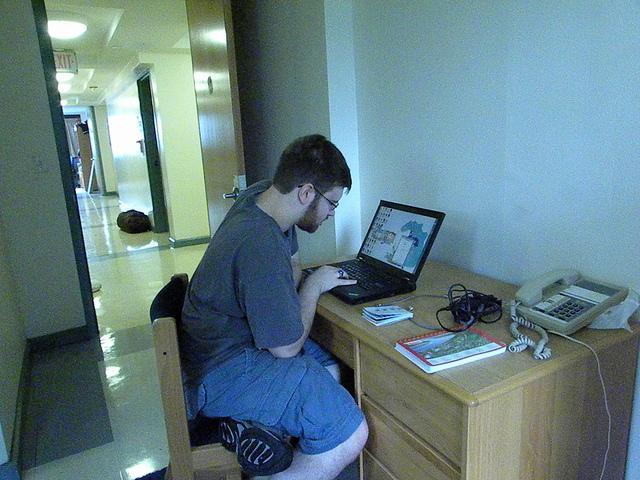How many books are there?
Give a very brief answer. 1. 